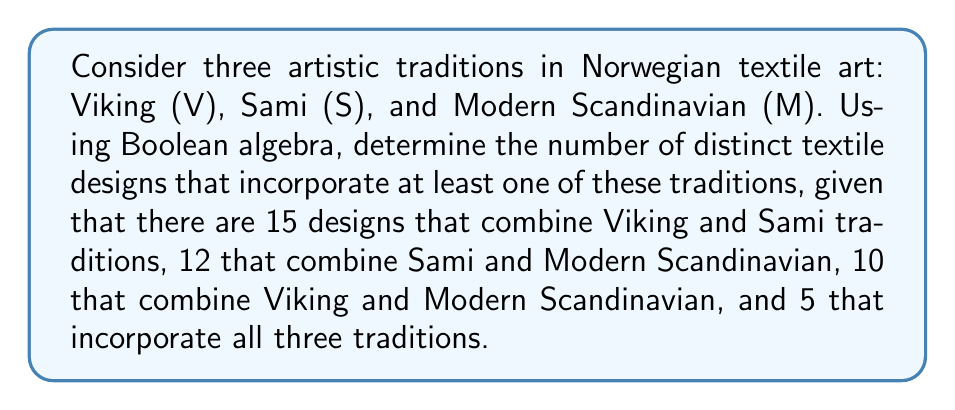Help me with this question. Let's approach this step-by-step using Boolean algebra and set theory:

1) Let's define our sets:
   V: Viking tradition
   S: Sami tradition
   M: Modern Scandinavian tradition

2) We're given the following information:
   $|V \cap S| = 15$
   $|S \cap M| = 12$
   $|V \cap M| = 10$
   $|V \cap S \cap M| = 5$

3) We need to find $|V \cup S \cup M|$, which represents all designs incorporating at least one tradition.

4) We can use the Inclusion-Exclusion Principle:
   $|V \cup S \cup M| = |V| + |S| + |M| - |V \cap S| - |V \cap M| - |S \cap M| + |V \cap S \cap M|$

5) We don't know $|V|$, $|S|$, or $|M|$ individually. Let's call these unknowns $a$, $b$, and $c$ respectively.

6) Substituting into our equation:
   $|V \cup S \cup M| = a + b + c - 15 - 10 - 12 + 5$

7) Simplifying:
   $|V \cup S \cup M| = a + b + c - 32$

8) This is as far as we can simplify without knowing the individual values of $a$, $b$, and $c$. The total number of distinct designs will be this sum minus 32.
Answer: $a + b + c - 32$ 